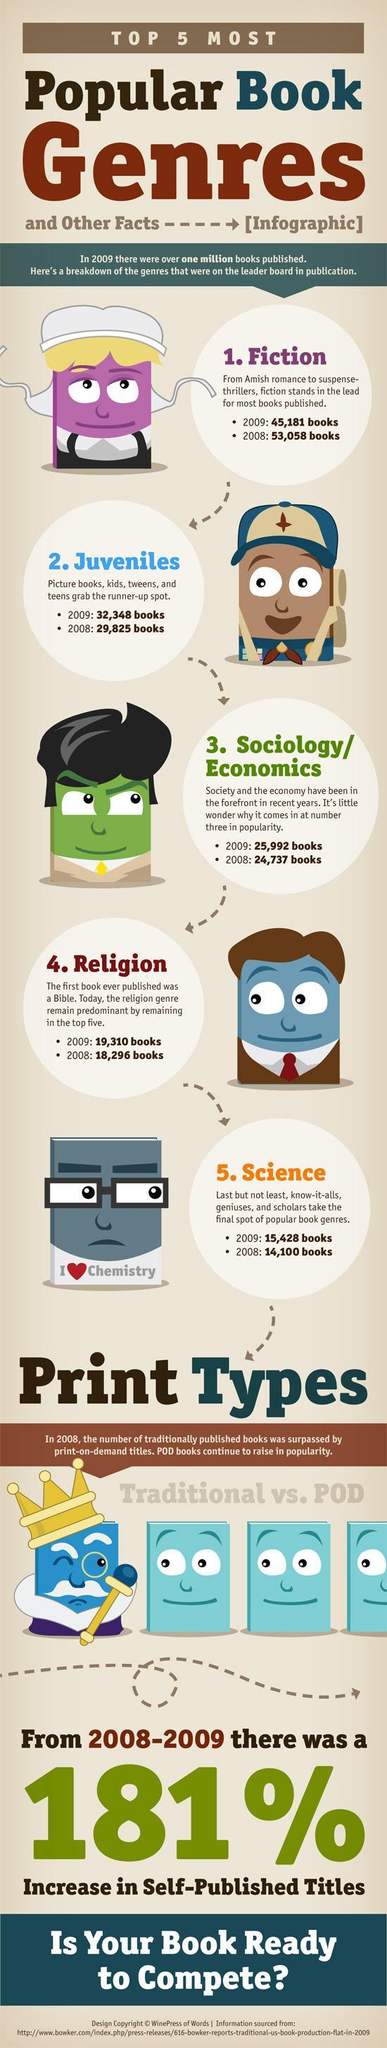What genre of books were most published in the year 2009?
Answer the question with a short phrase. Fiction How many science genre books were published in 2008? 14,100 What genre of books were least published in the year 2009? Science How many fiction genre books were published in 2008? 53,058 